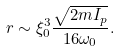Convert formula to latex. <formula><loc_0><loc_0><loc_500><loc_500>r \sim \xi _ { 0 } ^ { 3 } \frac { \sqrt { 2 m I _ { p } } } { 1 6 \omega _ { 0 } } .</formula> 